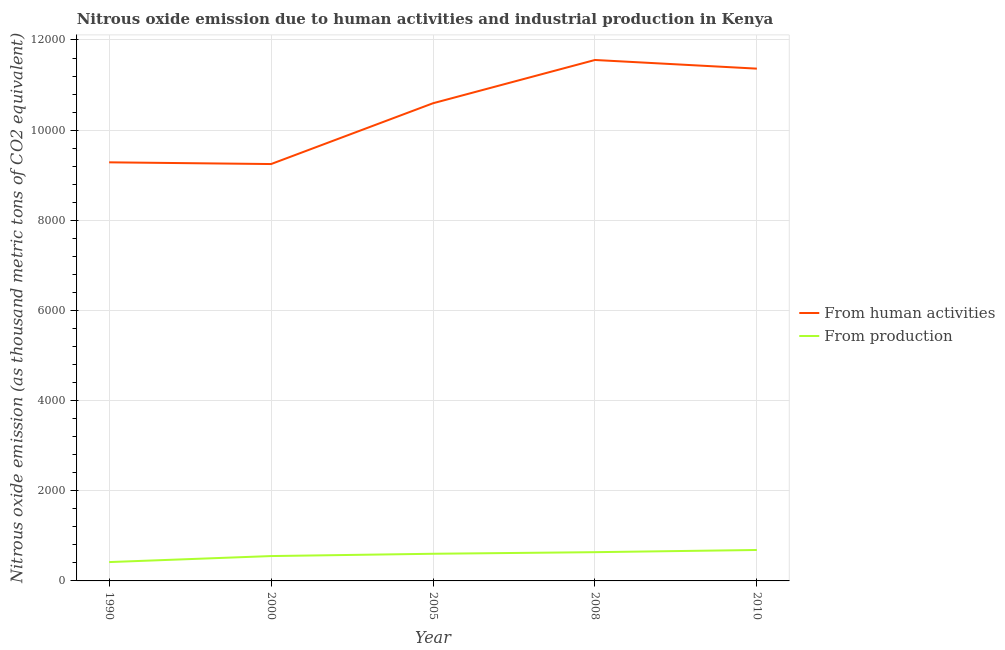How many different coloured lines are there?
Offer a very short reply. 2. What is the amount of emissions from human activities in 2005?
Make the answer very short. 1.06e+04. Across all years, what is the maximum amount of emissions from human activities?
Make the answer very short. 1.16e+04. Across all years, what is the minimum amount of emissions from human activities?
Provide a short and direct response. 9247.6. What is the total amount of emissions from human activities in the graph?
Your response must be concise. 5.21e+04. What is the difference between the amount of emissions from human activities in 1990 and that in 2000?
Your answer should be compact. 38.1. What is the difference between the amount of emissions from human activities in 2010 and the amount of emissions generated from industries in 2000?
Keep it short and to the point. 1.08e+04. What is the average amount of emissions from human activities per year?
Provide a short and direct response. 1.04e+04. In the year 2000, what is the difference between the amount of emissions from human activities and amount of emissions generated from industries?
Make the answer very short. 8696.1. In how many years, is the amount of emissions generated from industries greater than 4400 thousand metric tons?
Offer a very short reply. 0. What is the ratio of the amount of emissions from human activities in 1990 to that in 2000?
Ensure brevity in your answer.  1. What is the difference between the highest and the second highest amount of emissions from human activities?
Give a very brief answer. 192.1. What is the difference between the highest and the lowest amount of emissions generated from industries?
Keep it short and to the point. 268.4. In how many years, is the amount of emissions generated from industries greater than the average amount of emissions generated from industries taken over all years?
Your answer should be compact. 3. Is the sum of the amount of emissions generated from industries in 1990 and 2005 greater than the maximum amount of emissions from human activities across all years?
Your response must be concise. No. Is the amount of emissions generated from industries strictly greater than the amount of emissions from human activities over the years?
Offer a very short reply. No. Is the amount of emissions generated from industries strictly less than the amount of emissions from human activities over the years?
Offer a very short reply. Yes. How many lines are there?
Provide a succinct answer. 2. How many years are there in the graph?
Offer a very short reply. 5. Are the values on the major ticks of Y-axis written in scientific E-notation?
Ensure brevity in your answer.  No. Where does the legend appear in the graph?
Offer a terse response. Center right. How are the legend labels stacked?
Make the answer very short. Vertical. What is the title of the graph?
Keep it short and to the point. Nitrous oxide emission due to human activities and industrial production in Kenya. What is the label or title of the Y-axis?
Provide a succinct answer. Nitrous oxide emission (as thousand metric tons of CO2 equivalent). What is the Nitrous oxide emission (as thousand metric tons of CO2 equivalent) of From human activities in 1990?
Offer a very short reply. 9285.7. What is the Nitrous oxide emission (as thousand metric tons of CO2 equivalent) in From production in 1990?
Offer a terse response. 418. What is the Nitrous oxide emission (as thousand metric tons of CO2 equivalent) in From human activities in 2000?
Offer a very short reply. 9247.6. What is the Nitrous oxide emission (as thousand metric tons of CO2 equivalent) of From production in 2000?
Make the answer very short. 551.5. What is the Nitrous oxide emission (as thousand metric tons of CO2 equivalent) of From human activities in 2005?
Ensure brevity in your answer.  1.06e+04. What is the Nitrous oxide emission (as thousand metric tons of CO2 equivalent) of From production in 2005?
Offer a terse response. 602.4. What is the Nitrous oxide emission (as thousand metric tons of CO2 equivalent) in From human activities in 2008?
Keep it short and to the point. 1.16e+04. What is the Nitrous oxide emission (as thousand metric tons of CO2 equivalent) of From production in 2008?
Offer a terse response. 637.7. What is the Nitrous oxide emission (as thousand metric tons of CO2 equivalent) of From human activities in 2010?
Offer a very short reply. 1.14e+04. What is the Nitrous oxide emission (as thousand metric tons of CO2 equivalent) in From production in 2010?
Ensure brevity in your answer.  686.4. Across all years, what is the maximum Nitrous oxide emission (as thousand metric tons of CO2 equivalent) of From human activities?
Ensure brevity in your answer.  1.16e+04. Across all years, what is the maximum Nitrous oxide emission (as thousand metric tons of CO2 equivalent) of From production?
Give a very brief answer. 686.4. Across all years, what is the minimum Nitrous oxide emission (as thousand metric tons of CO2 equivalent) in From human activities?
Give a very brief answer. 9247.6. Across all years, what is the minimum Nitrous oxide emission (as thousand metric tons of CO2 equivalent) of From production?
Give a very brief answer. 418. What is the total Nitrous oxide emission (as thousand metric tons of CO2 equivalent) of From human activities in the graph?
Give a very brief answer. 5.21e+04. What is the total Nitrous oxide emission (as thousand metric tons of CO2 equivalent) of From production in the graph?
Provide a short and direct response. 2896. What is the difference between the Nitrous oxide emission (as thousand metric tons of CO2 equivalent) of From human activities in 1990 and that in 2000?
Offer a terse response. 38.1. What is the difference between the Nitrous oxide emission (as thousand metric tons of CO2 equivalent) of From production in 1990 and that in 2000?
Make the answer very short. -133.5. What is the difference between the Nitrous oxide emission (as thousand metric tons of CO2 equivalent) in From human activities in 1990 and that in 2005?
Give a very brief answer. -1310.7. What is the difference between the Nitrous oxide emission (as thousand metric tons of CO2 equivalent) of From production in 1990 and that in 2005?
Provide a succinct answer. -184.4. What is the difference between the Nitrous oxide emission (as thousand metric tons of CO2 equivalent) in From human activities in 1990 and that in 2008?
Ensure brevity in your answer.  -2270.6. What is the difference between the Nitrous oxide emission (as thousand metric tons of CO2 equivalent) of From production in 1990 and that in 2008?
Your response must be concise. -219.7. What is the difference between the Nitrous oxide emission (as thousand metric tons of CO2 equivalent) of From human activities in 1990 and that in 2010?
Your response must be concise. -2078.5. What is the difference between the Nitrous oxide emission (as thousand metric tons of CO2 equivalent) in From production in 1990 and that in 2010?
Provide a short and direct response. -268.4. What is the difference between the Nitrous oxide emission (as thousand metric tons of CO2 equivalent) in From human activities in 2000 and that in 2005?
Ensure brevity in your answer.  -1348.8. What is the difference between the Nitrous oxide emission (as thousand metric tons of CO2 equivalent) in From production in 2000 and that in 2005?
Keep it short and to the point. -50.9. What is the difference between the Nitrous oxide emission (as thousand metric tons of CO2 equivalent) of From human activities in 2000 and that in 2008?
Give a very brief answer. -2308.7. What is the difference between the Nitrous oxide emission (as thousand metric tons of CO2 equivalent) of From production in 2000 and that in 2008?
Your answer should be compact. -86.2. What is the difference between the Nitrous oxide emission (as thousand metric tons of CO2 equivalent) in From human activities in 2000 and that in 2010?
Your answer should be very brief. -2116.6. What is the difference between the Nitrous oxide emission (as thousand metric tons of CO2 equivalent) of From production in 2000 and that in 2010?
Provide a succinct answer. -134.9. What is the difference between the Nitrous oxide emission (as thousand metric tons of CO2 equivalent) of From human activities in 2005 and that in 2008?
Keep it short and to the point. -959.9. What is the difference between the Nitrous oxide emission (as thousand metric tons of CO2 equivalent) in From production in 2005 and that in 2008?
Your answer should be compact. -35.3. What is the difference between the Nitrous oxide emission (as thousand metric tons of CO2 equivalent) in From human activities in 2005 and that in 2010?
Ensure brevity in your answer.  -767.8. What is the difference between the Nitrous oxide emission (as thousand metric tons of CO2 equivalent) in From production in 2005 and that in 2010?
Provide a short and direct response. -84. What is the difference between the Nitrous oxide emission (as thousand metric tons of CO2 equivalent) in From human activities in 2008 and that in 2010?
Your answer should be very brief. 192.1. What is the difference between the Nitrous oxide emission (as thousand metric tons of CO2 equivalent) in From production in 2008 and that in 2010?
Make the answer very short. -48.7. What is the difference between the Nitrous oxide emission (as thousand metric tons of CO2 equivalent) in From human activities in 1990 and the Nitrous oxide emission (as thousand metric tons of CO2 equivalent) in From production in 2000?
Keep it short and to the point. 8734.2. What is the difference between the Nitrous oxide emission (as thousand metric tons of CO2 equivalent) in From human activities in 1990 and the Nitrous oxide emission (as thousand metric tons of CO2 equivalent) in From production in 2005?
Make the answer very short. 8683.3. What is the difference between the Nitrous oxide emission (as thousand metric tons of CO2 equivalent) in From human activities in 1990 and the Nitrous oxide emission (as thousand metric tons of CO2 equivalent) in From production in 2008?
Keep it short and to the point. 8648. What is the difference between the Nitrous oxide emission (as thousand metric tons of CO2 equivalent) of From human activities in 1990 and the Nitrous oxide emission (as thousand metric tons of CO2 equivalent) of From production in 2010?
Make the answer very short. 8599.3. What is the difference between the Nitrous oxide emission (as thousand metric tons of CO2 equivalent) of From human activities in 2000 and the Nitrous oxide emission (as thousand metric tons of CO2 equivalent) of From production in 2005?
Your answer should be very brief. 8645.2. What is the difference between the Nitrous oxide emission (as thousand metric tons of CO2 equivalent) in From human activities in 2000 and the Nitrous oxide emission (as thousand metric tons of CO2 equivalent) in From production in 2008?
Provide a succinct answer. 8609.9. What is the difference between the Nitrous oxide emission (as thousand metric tons of CO2 equivalent) in From human activities in 2000 and the Nitrous oxide emission (as thousand metric tons of CO2 equivalent) in From production in 2010?
Make the answer very short. 8561.2. What is the difference between the Nitrous oxide emission (as thousand metric tons of CO2 equivalent) of From human activities in 2005 and the Nitrous oxide emission (as thousand metric tons of CO2 equivalent) of From production in 2008?
Provide a short and direct response. 9958.7. What is the difference between the Nitrous oxide emission (as thousand metric tons of CO2 equivalent) in From human activities in 2005 and the Nitrous oxide emission (as thousand metric tons of CO2 equivalent) in From production in 2010?
Provide a short and direct response. 9910. What is the difference between the Nitrous oxide emission (as thousand metric tons of CO2 equivalent) of From human activities in 2008 and the Nitrous oxide emission (as thousand metric tons of CO2 equivalent) of From production in 2010?
Ensure brevity in your answer.  1.09e+04. What is the average Nitrous oxide emission (as thousand metric tons of CO2 equivalent) of From human activities per year?
Keep it short and to the point. 1.04e+04. What is the average Nitrous oxide emission (as thousand metric tons of CO2 equivalent) in From production per year?
Provide a short and direct response. 579.2. In the year 1990, what is the difference between the Nitrous oxide emission (as thousand metric tons of CO2 equivalent) in From human activities and Nitrous oxide emission (as thousand metric tons of CO2 equivalent) in From production?
Provide a succinct answer. 8867.7. In the year 2000, what is the difference between the Nitrous oxide emission (as thousand metric tons of CO2 equivalent) of From human activities and Nitrous oxide emission (as thousand metric tons of CO2 equivalent) of From production?
Provide a short and direct response. 8696.1. In the year 2005, what is the difference between the Nitrous oxide emission (as thousand metric tons of CO2 equivalent) of From human activities and Nitrous oxide emission (as thousand metric tons of CO2 equivalent) of From production?
Make the answer very short. 9994. In the year 2008, what is the difference between the Nitrous oxide emission (as thousand metric tons of CO2 equivalent) of From human activities and Nitrous oxide emission (as thousand metric tons of CO2 equivalent) of From production?
Provide a succinct answer. 1.09e+04. In the year 2010, what is the difference between the Nitrous oxide emission (as thousand metric tons of CO2 equivalent) of From human activities and Nitrous oxide emission (as thousand metric tons of CO2 equivalent) of From production?
Make the answer very short. 1.07e+04. What is the ratio of the Nitrous oxide emission (as thousand metric tons of CO2 equivalent) in From human activities in 1990 to that in 2000?
Your answer should be compact. 1. What is the ratio of the Nitrous oxide emission (as thousand metric tons of CO2 equivalent) of From production in 1990 to that in 2000?
Keep it short and to the point. 0.76. What is the ratio of the Nitrous oxide emission (as thousand metric tons of CO2 equivalent) in From human activities in 1990 to that in 2005?
Make the answer very short. 0.88. What is the ratio of the Nitrous oxide emission (as thousand metric tons of CO2 equivalent) of From production in 1990 to that in 2005?
Ensure brevity in your answer.  0.69. What is the ratio of the Nitrous oxide emission (as thousand metric tons of CO2 equivalent) in From human activities in 1990 to that in 2008?
Keep it short and to the point. 0.8. What is the ratio of the Nitrous oxide emission (as thousand metric tons of CO2 equivalent) in From production in 1990 to that in 2008?
Make the answer very short. 0.66. What is the ratio of the Nitrous oxide emission (as thousand metric tons of CO2 equivalent) in From human activities in 1990 to that in 2010?
Keep it short and to the point. 0.82. What is the ratio of the Nitrous oxide emission (as thousand metric tons of CO2 equivalent) of From production in 1990 to that in 2010?
Offer a terse response. 0.61. What is the ratio of the Nitrous oxide emission (as thousand metric tons of CO2 equivalent) of From human activities in 2000 to that in 2005?
Provide a short and direct response. 0.87. What is the ratio of the Nitrous oxide emission (as thousand metric tons of CO2 equivalent) of From production in 2000 to that in 2005?
Ensure brevity in your answer.  0.92. What is the ratio of the Nitrous oxide emission (as thousand metric tons of CO2 equivalent) in From human activities in 2000 to that in 2008?
Provide a succinct answer. 0.8. What is the ratio of the Nitrous oxide emission (as thousand metric tons of CO2 equivalent) of From production in 2000 to that in 2008?
Your answer should be compact. 0.86. What is the ratio of the Nitrous oxide emission (as thousand metric tons of CO2 equivalent) in From human activities in 2000 to that in 2010?
Offer a very short reply. 0.81. What is the ratio of the Nitrous oxide emission (as thousand metric tons of CO2 equivalent) of From production in 2000 to that in 2010?
Ensure brevity in your answer.  0.8. What is the ratio of the Nitrous oxide emission (as thousand metric tons of CO2 equivalent) of From human activities in 2005 to that in 2008?
Offer a terse response. 0.92. What is the ratio of the Nitrous oxide emission (as thousand metric tons of CO2 equivalent) of From production in 2005 to that in 2008?
Ensure brevity in your answer.  0.94. What is the ratio of the Nitrous oxide emission (as thousand metric tons of CO2 equivalent) in From human activities in 2005 to that in 2010?
Your answer should be very brief. 0.93. What is the ratio of the Nitrous oxide emission (as thousand metric tons of CO2 equivalent) in From production in 2005 to that in 2010?
Your answer should be very brief. 0.88. What is the ratio of the Nitrous oxide emission (as thousand metric tons of CO2 equivalent) of From human activities in 2008 to that in 2010?
Offer a very short reply. 1.02. What is the ratio of the Nitrous oxide emission (as thousand metric tons of CO2 equivalent) of From production in 2008 to that in 2010?
Make the answer very short. 0.93. What is the difference between the highest and the second highest Nitrous oxide emission (as thousand metric tons of CO2 equivalent) in From human activities?
Provide a succinct answer. 192.1. What is the difference between the highest and the second highest Nitrous oxide emission (as thousand metric tons of CO2 equivalent) in From production?
Offer a very short reply. 48.7. What is the difference between the highest and the lowest Nitrous oxide emission (as thousand metric tons of CO2 equivalent) of From human activities?
Provide a short and direct response. 2308.7. What is the difference between the highest and the lowest Nitrous oxide emission (as thousand metric tons of CO2 equivalent) in From production?
Offer a terse response. 268.4. 